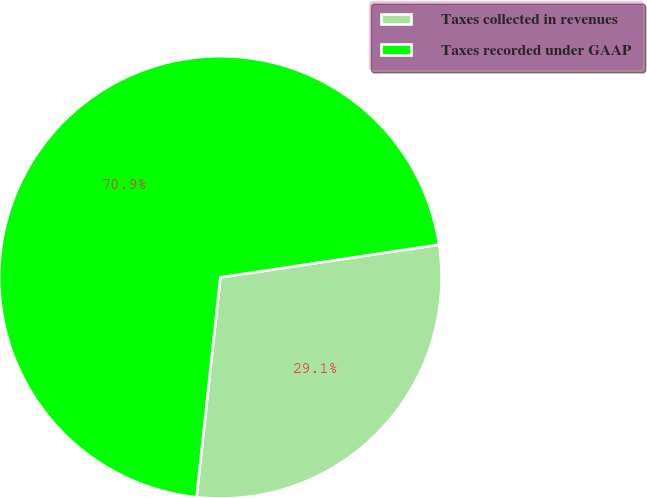Convert chart to OTSL. <chart><loc_0><loc_0><loc_500><loc_500><pie_chart><fcel>Taxes collected in revenues<fcel>Taxes recorded under GAAP<nl><fcel>29.08%<fcel>70.92%<nl></chart> 